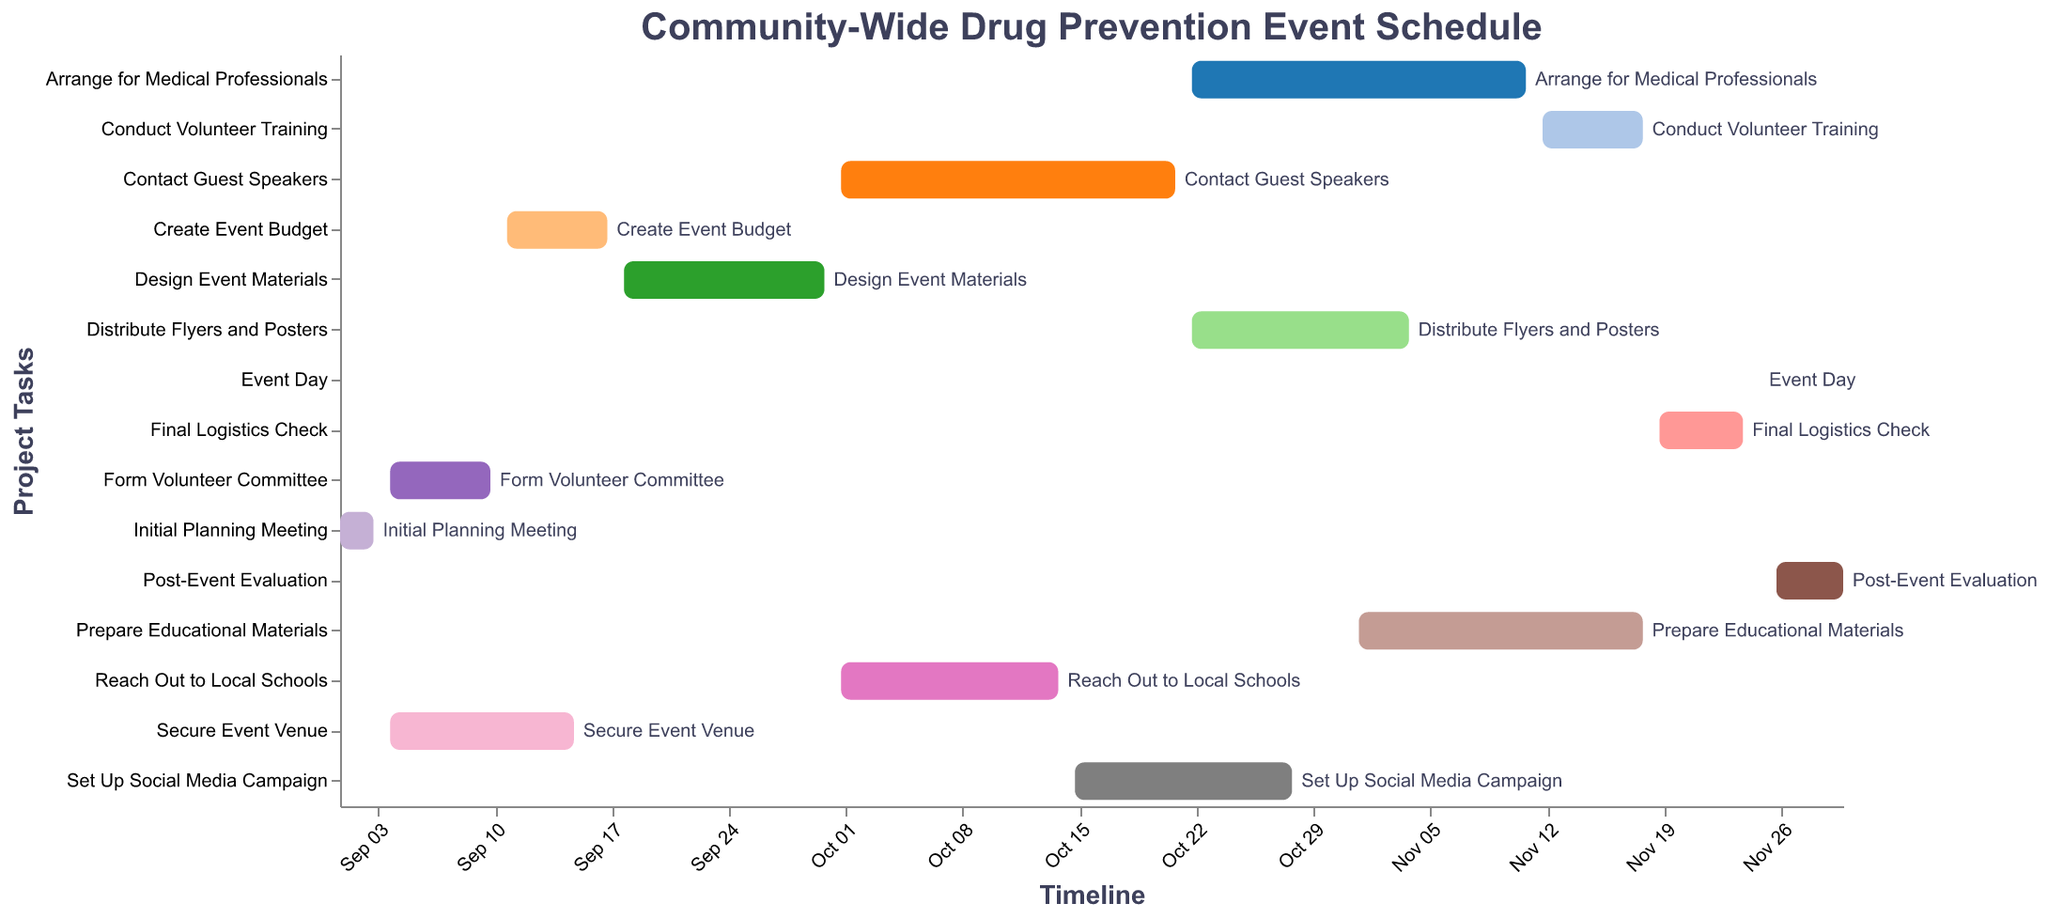What is the duration of the 'Initial Planning Meeting' task? The 'Initial Planning Meeting' task starts on 2023-09-01 and ends on 2023-09-03. The duration is calculated by finding the difference between the end date and the start date. So, 2023-09-03 minus 2023-09-01 equals 2 days.
Answer: 2 days Which task has the longest duration? By examining the Gantt chart, we can see the tasks labeled with their start and end dates. The task 'Arrange for Medical Professionals' starts on 2023-10-22 and ends on 2023-11-11, which totals 20 days, making it the longest duration.
Answer: Arrange for Medical Professionals When does the 'Distribute Flyers and Posters' task start and end? The 'Distribute Flyers and Posters' task starts on 2023-10-22 and ends on 2023-11-04. These dates can be directly observed from the corresponding bar in the Gantt chart.
Answer: 2023-10-22 to 2023-11-04 How many tasks start in October? By checking the start dates for each task, we find that 'Reach Out to Local Schools' (2023-10-01), ‘Contact Guest Speakers’ (2023-10-01), ‘Set Up Social Media Campaign’ (2023-10-15), ‘Distribute Flyers and Posters’ (2023-10-22), and ‘Arrange for Medical Professionals’ (2023-10-22) all start in October. Thus, five tasks start in October.
Answer: 5 Which two tasks have overlapping timelines between October and November? 'Distribute Flyers and Posters' overlaps from 2023-10-22 to 2023-11-04 and 'Arrange for Medical Professionals' overlaps from 2023-10-22 to 2023-11-11. Both tasks overlap in this period.
Answer: Distribute Flyers and Posters, Arrange for Medical Professionals Does any task start on the same day as another? By examining the start dates, both 'Form Volunteer Committee' and 'Secure Event Venue' start on 2023-09-04. Similarly, 'Reach Out to Local Schools' and 'Contact Guest Speakers' both start on 2023-10-01, and 'Distribute Flyers and Posters' and 'Arrange for Medical Professionals' start on 2023-10-22.
Answer: Yes Which tasks are scheduled consecutively in November? 'Conduct Volunteer Training' ends on 2023-11-18, followed directly by 'Final Logistics Check' which starts on 2023-11-19 and ends on 2023-11-24. The event day is on 2023-11-25, followed by 'Post-Event Evaluation' from 2023-11-26 to 2023-11-30.
Answer: Conduct Volunteer Training, Final Logistics Check, Event Day, Post-Event Evaluation What are the tasks scheduled after November 10th? The tasks listed after November 10th include 'Prepare Educational Materials' (from 2023-11-01 to 2023-11-18 overlaps), 'Conduct Volunteer Training' (2023-11-12 to 2023-11-18), 'Final Logistics Check' (2023-11-19 to 2023-11-24), 'Event Day' (2023-11-25), and 'Post-Event Evaluation' (2023-11-26 to 2023-11-30).
Answer: Prepare Educational Materials, Conduct Volunteer Training, Final Logistics Check, Event Day, Post-Event Evaluation 